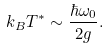<formula> <loc_0><loc_0><loc_500><loc_500>k _ { B } T ^ { * } \sim \frac { \hbar { \omega } _ { 0 } } { 2 g } .</formula> 